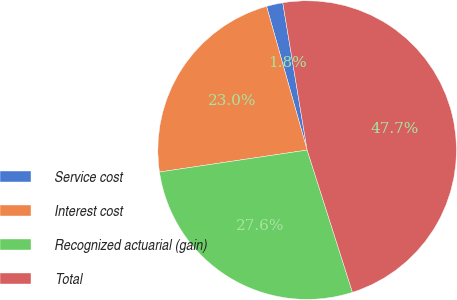Convert chart to OTSL. <chart><loc_0><loc_0><loc_500><loc_500><pie_chart><fcel>Service cost<fcel>Interest cost<fcel>Recognized actuarial (gain)<fcel>Total<nl><fcel>1.77%<fcel>22.97%<fcel>27.56%<fcel>47.7%<nl></chart> 